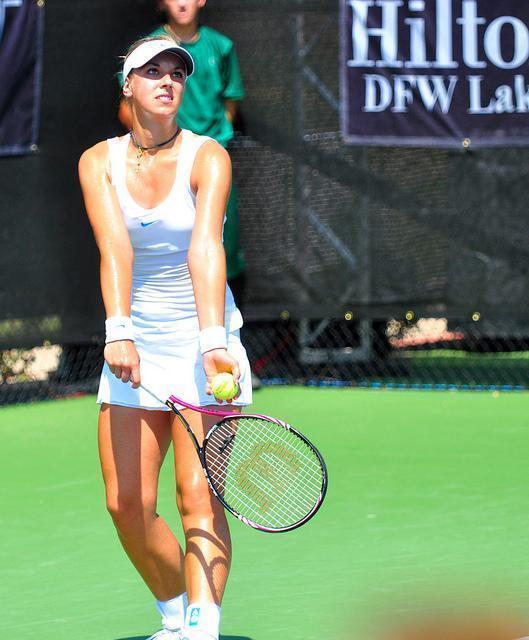Why is she holding the ball?
Choose the right answer and clarify with the format: 'Answer: answer
Rationale: rationale.'
Options: Will serve, for sale, hiding it, will throw. Answer: will serve.
Rationale: The woman is serving. 